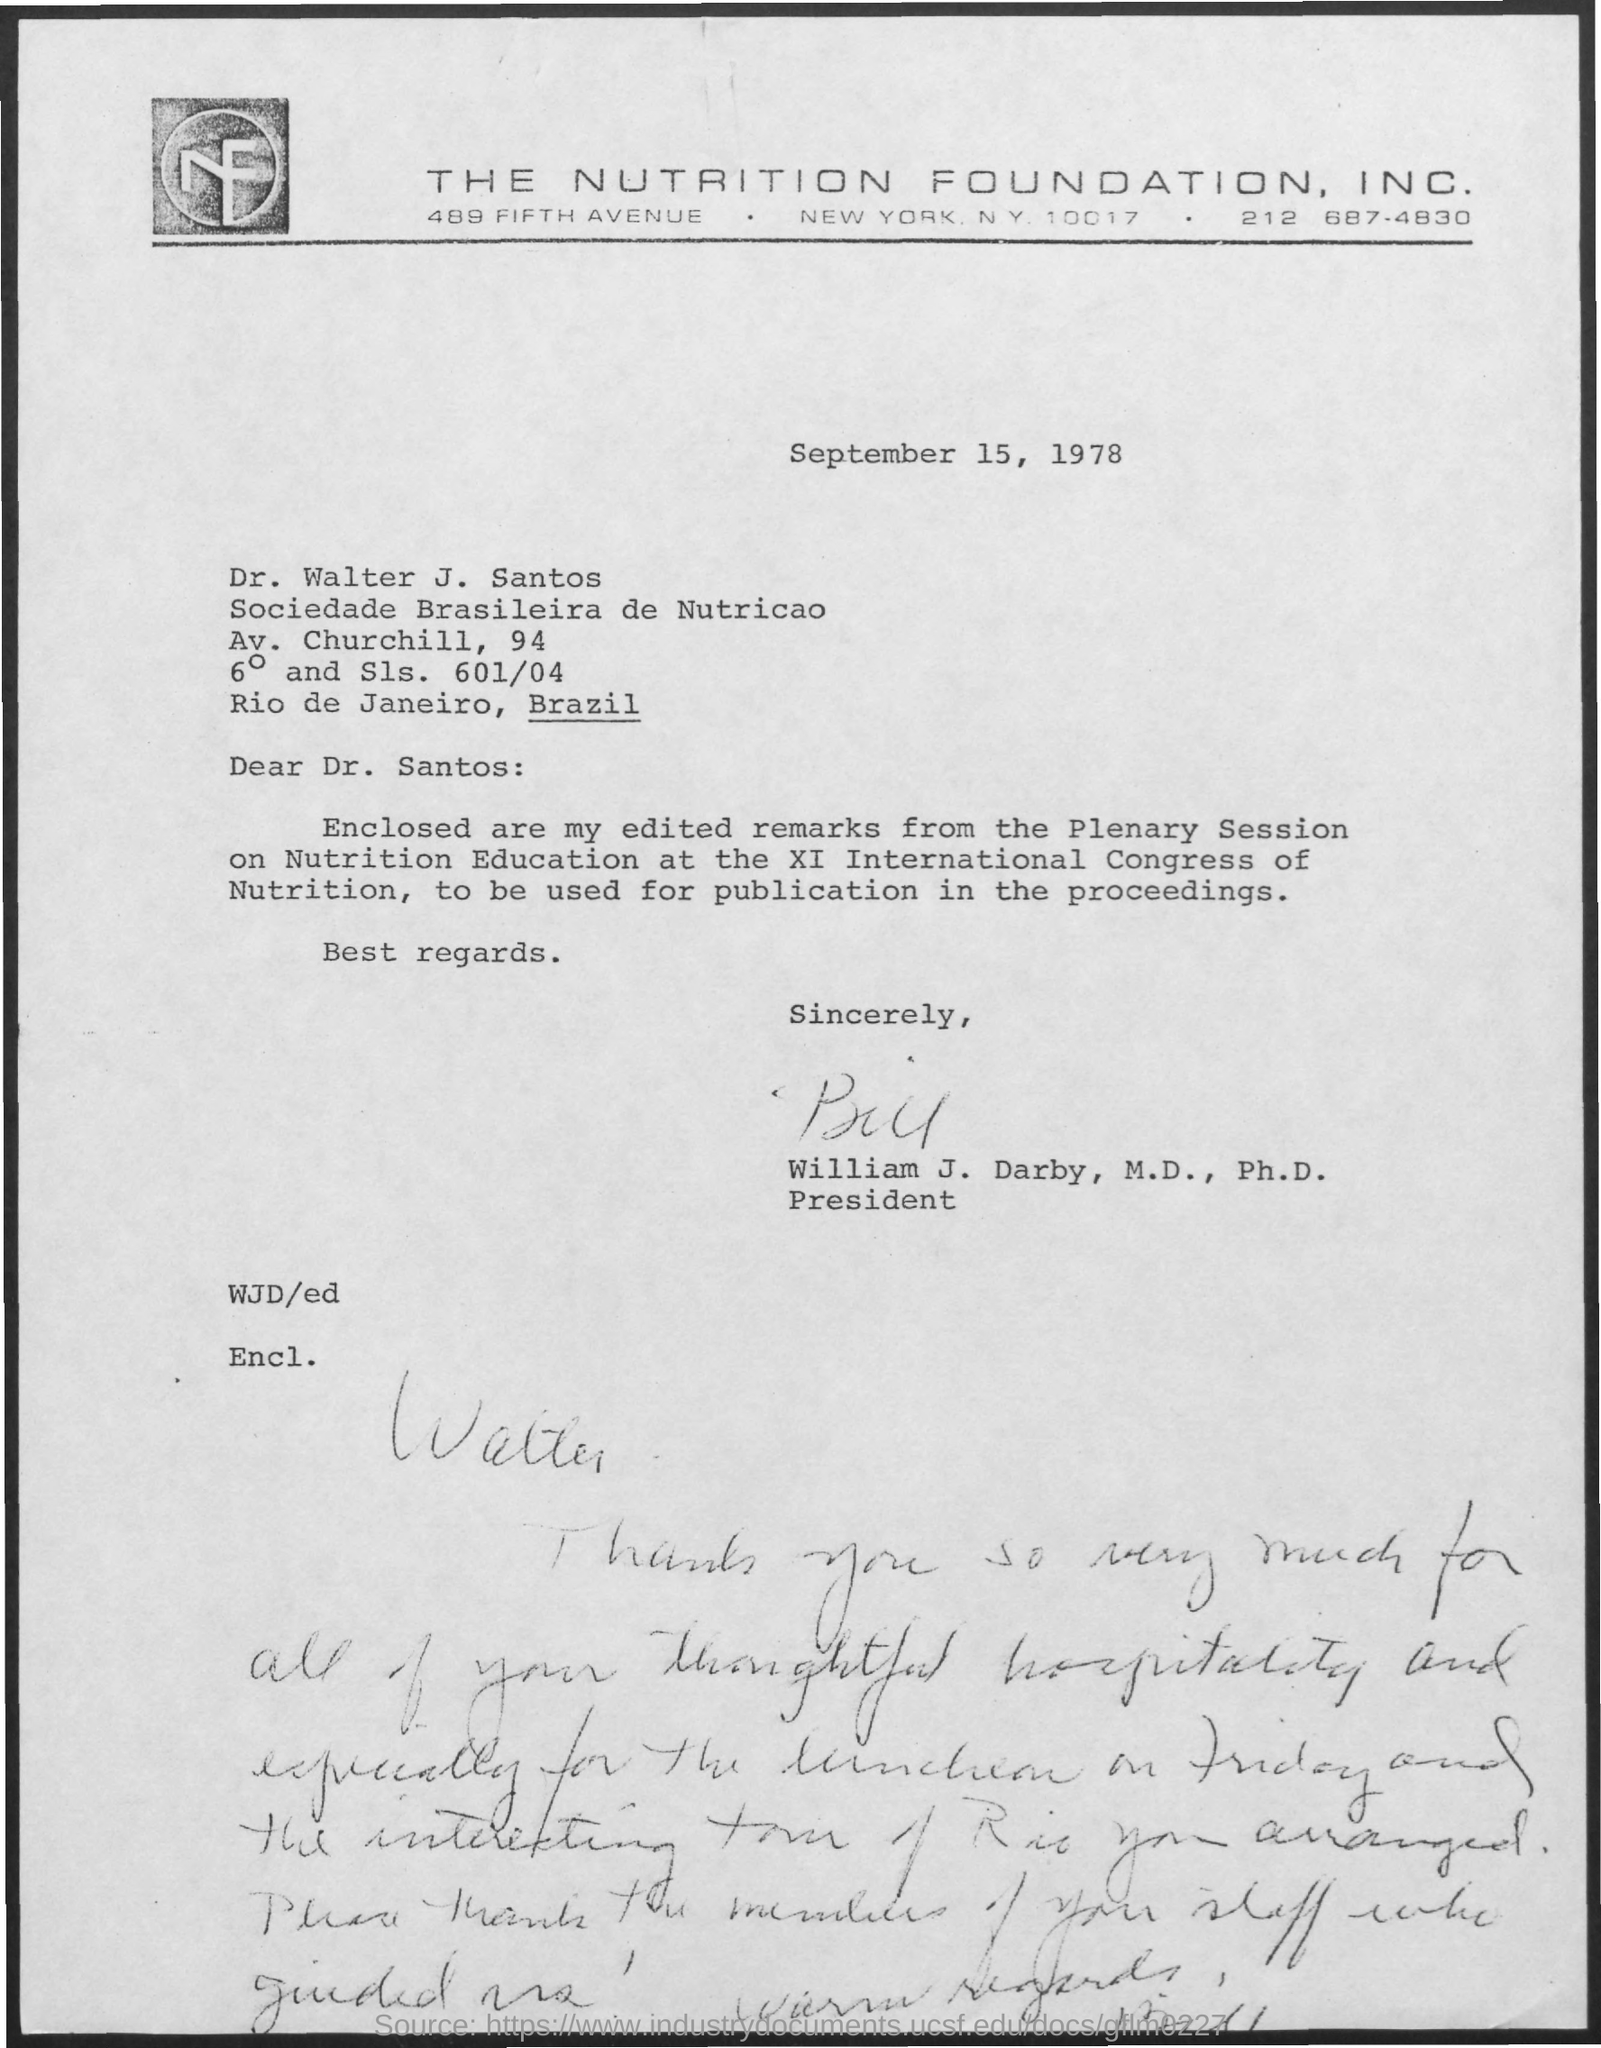Mention a couple of crucial points in this snapshot. The letter was written on September 15, 1978. The document was signed by William J. Darby, M.D., Ph.D. 